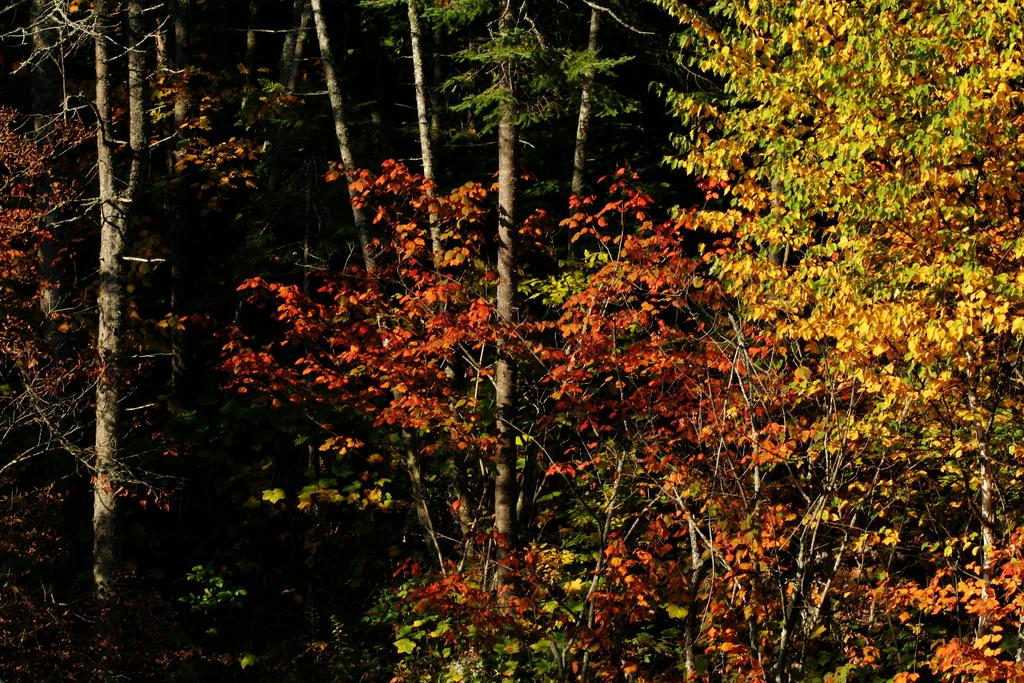What type of vegetation can be seen on the trees in the image? There are colorful leaves on the trees in the image. What statement is being made by the leaves on the trees in the image? The leaves on the trees in the image are not making a statement; they are simply a natural part of the trees. 